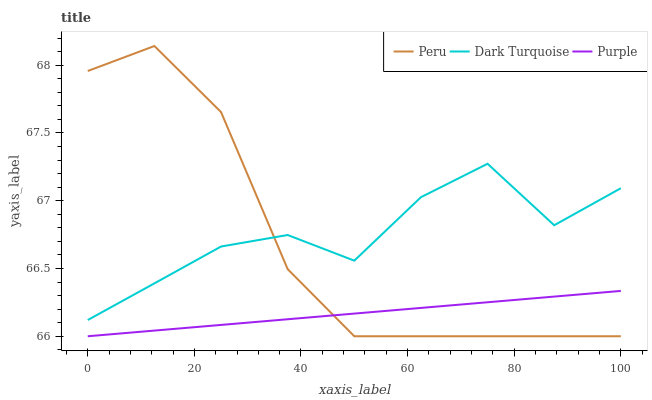Does Purple have the minimum area under the curve?
Answer yes or no. Yes. Does Dark Turquoise have the maximum area under the curve?
Answer yes or no. Yes. Does Peru have the minimum area under the curve?
Answer yes or no. No. Does Peru have the maximum area under the curve?
Answer yes or no. No. Is Purple the smoothest?
Answer yes or no. Yes. Is Dark Turquoise the roughest?
Answer yes or no. Yes. Is Peru the smoothest?
Answer yes or no. No. Is Peru the roughest?
Answer yes or no. No. Does Purple have the lowest value?
Answer yes or no. Yes. Does Dark Turquoise have the lowest value?
Answer yes or no. No. Does Peru have the highest value?
Answer yes or no. Yes. Does Dark Turquoise have the highest value?
Answer yes or no. No. Is Purple less than Dark Turquoise?
Answer yes or no. Yes. Is Dark Turquoise greater than Purple?
Answer yes or no. Yes. Does Purple intersect Peru?
Answer yes or no. Yes. Is Purple less than Peru?
Answer yes or no. No. Is Purple greater than Peru?
Answer yes or no. No. Does Purple intersect Dark Turquoise?
Answer yes or no. No. 